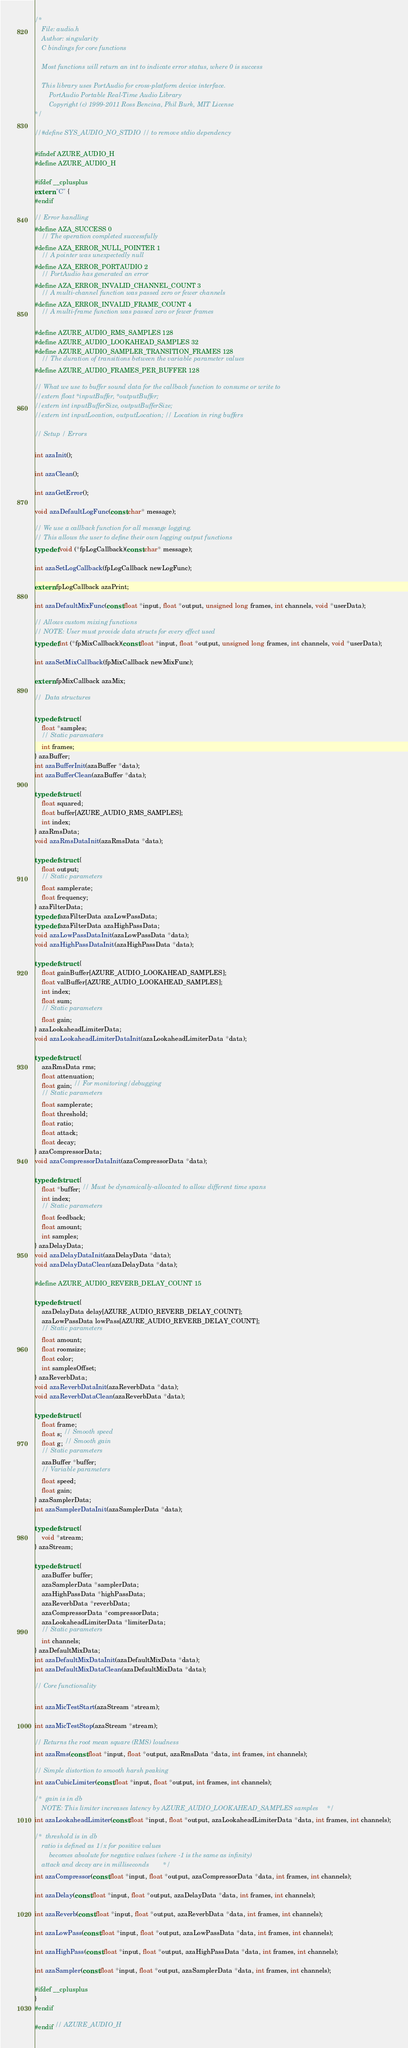Convert code to text. <code><loc_0><loc_0><loc_500><loc_500><_C_>/*
    File: audio.h
    Author: singularity
    C bindings for core functions

    Most functions will return an int to indicate error status, where 0 is success

    This library uses PortAudio for cross-platform device interface.
        PortAudio Portable Real-Time Audio Library
        Copyright (c) 1999-2011 Ross Bencina, Phil Burk, MIT License
*/

//#define SYS_AUDIO_NO_STDIO // to remove stdio dependency

#ifndef AZURE_AUDIO_H
#define AZURE_AUDIO_H

#ifdef __cplusplus
extern "C" {
#endif

// Error handling
#define AZA_SUCCESS 0
    // The operation completed successfully
#define AZA_ERROR_NULL_POINTER 1
    // A pointer was unexpectedly null
#define AZA_ERROR_PORTAUDIO 2
    // PortAudio has generated an error
#define AZA_ERROR_INVALID_CHANNEL_COUNT 3
    // A multi-channel function was passed zero or fewer channels
#define AZA_ERROR_INVALID_FRAME_COUNT 4
    // A multi-frame function was passed zero or fewer frames

#define AZURE_AUDIO_RMS_SAMPLES 128
#define AZURE_AUDIO_LOOKAHEAD_SAMPLES 32
#define AZURE_AUDIO_SAMPLER_TRANSITION_FRAMES 128
    // The duration of transitions between the variable parameter values
#define AZURE_AUDIO_FRAMES_PER_BUFFER 128

// What we use to buffer sound data for the callback function to consume or write to
//extern float *inputBuffer, *outputBuffer;
//extern int inputBufferSize, outputBufferSize;
//extern int inputLocation, outputLocation; // Location in ring buffers

// Setup / Errors

int azaInit();

int azaClean();

int azaGetError();

void azaDefaultLogFunc(const char* message);

// We use a callback function for all message logging.
// This allows the user to define their own logging output functions
typedef void (*fpLogCallback)(const char* message);

int azaSetLogCallback(fpLogCallback newLogFunc);

extern fpLogCallback azaPrint;

int azaDefaultMixFunc(const float *input, float *output, unsigned long frames, int channels, void *userData);

// Allows custom mixing functions
// NOTE: User must provide data structs for every effect used
typedef int (*fpMixCallback)(const float *input, float *output, unsigned long frames, int channels, void *userData);

int azaSetMixCallback(fpMixCallback newMixFunc);

extern fpMixCallback azaMix;

//  Data structures

typedef struct {
    float *samples;
    // Static paramaters
    int frames;
} azaBuffer;
int azaBufferInit(azaBuffer *data);
int azaBufferClean(azaBuffer *data);

typedef struct {
    float squared;
    float buffer[AZURE_AUDIO_RMS_SAMPLES];
    int index;
} azaRmsData;
void azaRmsDataInit(azaRmsData *data);

typedef struct {
    float output;
    // Static parameters
    float samplerate;
    float frequency;
} azaFilterData;
typedef azaFilterData azaLowPassData;
typedef azaFilterData azaHighPassData;
void azaLowPassDataInit(azaLowPassData *data);
void azaHighPassDataInit(azaHighPassData *data);

typedef struct {
    float gainBuffer[AZURE_AUDIO_LOOKAHEAD_SAMPLES];
    float valBuffer[AZURE_AUDIO_LOOKAHEAD_SAMPLES];
    int index;
    float sum;
    // Static parameters
    float gain;
} azaLookaheadLimiterData;
void azaLookaheadLimiterDataInit(azaLookaheadLimiterData *data);

typedef struct {
    azaRmsData rms;
    float attenuation;
    float gain; // For monitoring/debugging
    // Static parameters
    float samplerate;
    float threshold;
    float ratio;
    float attack;
    float decay;
} azaCompressorData;
void azaCompressorDataInit(azaCompressorData *data);

typedef struct {
    float *buffer; // Must be dynamically-allocated to allow different time spans
    int index;
    // Static parameters
    float feedback;
    float amount;
    int samples;
} azaDelayData;
void azaDelayDataInit(azaDelayData *data);
void azaDelayDataClean(azaDelayData *data);

#define AZURE_AUDIO_REVERB_DELAY_COUNT 15

typedef struct {
    azaDelayData delay[AZURE_AUDIO_REVERB_DELAY_COUNT];
    azaLowPassData lowPass[AZURE_AUDIO_REVERB_DELAY_COUNT];
    // Static parameters
    float amount;
    float roomsize;
    float color;
    int samplesOffset;
} azaReverbData;
void azaReverbDataInit(azaReverbData *data);
void azaReverbDataClean(azaReverbData *data);

typedef struct {
    float frame;
    float s; // Smooth speed
    float g; // Smooth gain
    // Static parameters
    azaBuffer *buffer;
    // Variable parameters
    float speed;
    float gain;
} azaSamplerData;
int azaSamplerDataInit(azaSamplerData *data);

typedef struct {
    void *stream;
} azaStream;

typedef struct {
    azaBuffer buffer;
    azaSamplerData *samplerData;
    azaHighPassData *highPassData;
    azaReverbData *reverbData;
    azaCompressorData *compressorData;
    azaLookaheadLimiterData *limiterData;
    // Static parameters
    int channels;
} azaDefaultMixData;
int azaDefaultMixDataInit(azaDefaultMixData *data);
int azaDefaultMixDataClean(azaDefaultMixData *data);

// Core functionality

int azaMicTestStart(azaStream *stream);

int azaMicTestStop(azaStream *stream);

// Returns the root mean square (RMS) loudness
int azaRms(const float *input, float *output, azaRmsData *data, int frames, int channels);

// Simple distortion to smooth harsh peaking
int azaCubicLimiter(const float *input, float *output, int frames, int channels);

/*  gain is in db
    NOTE: This limiter increases latency by AZURE_AUDIO_LOOKAHEAD_SAMPLES samples     */
int azaLookaheadLimiter(const float *input, float *output, azaLookaheadLimiterData *data, int frames, int channels);

/*  threshold is in db
    ratio is defined as 1/x for positive values
        becomes absolute for negative values (where -1 is the same as infinity)
    attack and decay are in milliseconds        */
int azaCompressor(const float *input, float *output, azaCompressorData *data, int frames, int channels);

int azaDelay(const float *input, float *output, azaDelayData *data, int frames, int channels);

int azaReverb(const float *input, float *output, azaReverbData *data, int frames, int channels);

int azaLowPass(const float *input, float *output, azaLowPassData *data, int frames, int channels);

int azaHighPass(const float *input, float *output, azaHighPassData *data, int frames, int channels);

int azaSampler(const float *input, float *output, azaSamplerData *data, int frames, int channels);

#ifdef __cplusplus
}
#endif

#endif // AZURE_AUDIO_H
</code> 